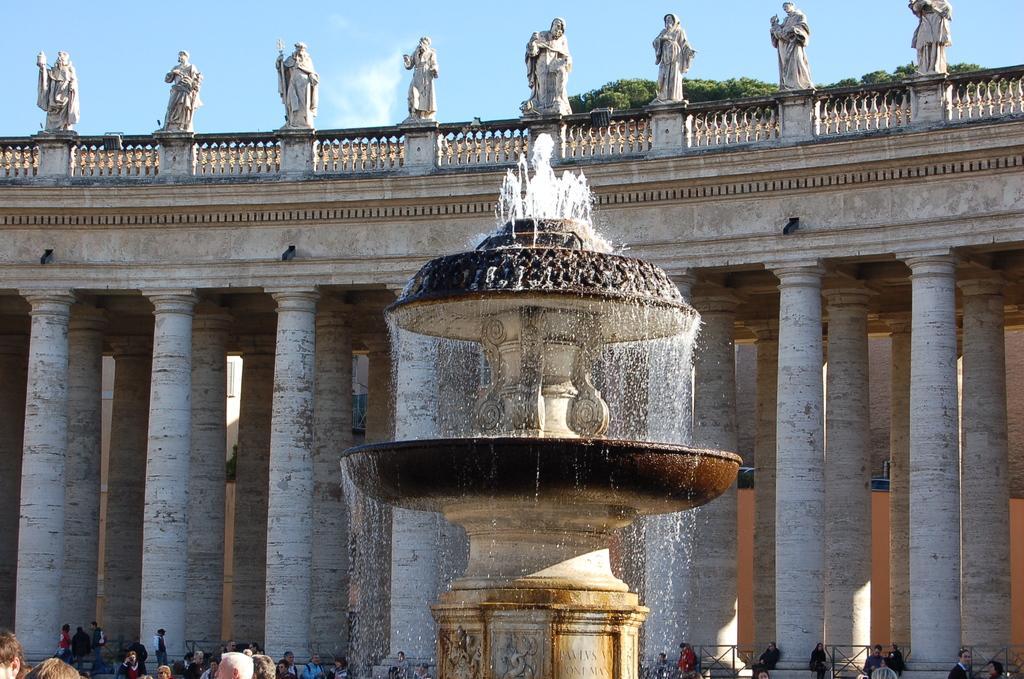Could you give a brief overview of what you see in this image? In this picture we can see a fountain, water, pillars, statues, trees, some objects and a group of people and in the background we can see the sky. 